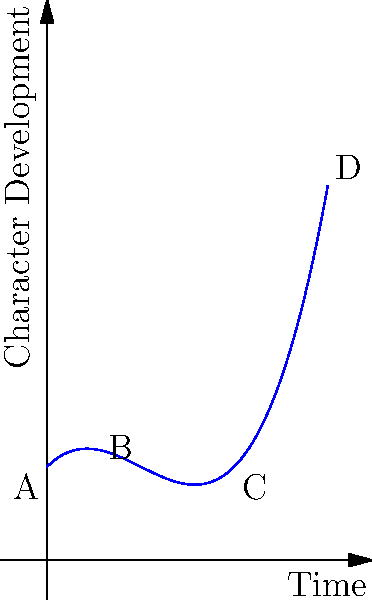In your novel, you're plotting a character's development arc over time. The curve above represents this arc, where the x-axis is time and the y-axis is the level of character development. If the function for this curve is $f(x) = 0.5x^3 - 1.5x^2 + x + 1$, at what point in time does the character experience the most significant setback in their development? To find the point of the most significant setback, we need to determine where the curve has its minimum value within the given time frame. This can be done by following these steps:

1) First, we need to find the derivative of the function:
   $f'(x) = 1.5x^2 - 3x + 1$

2) To find the critical points, set $f'(x) = 0$:
   $1.5x^2 - 3x + 1 = 0$

3) Solve this quadratic equation:
   $a = 1.5$, $b = -3$, $c = 1$
   $x = \frac{-b \pm \sqrt{b^2 - 4ac}}{2a}$
   $x = \frac{3 \pm \sqrt{9 - 6}}{3} = \frac{3 \pm \sqrt{3}}{3}$

4) This gives us two critical points:
   $x_1 = \frac{3 + \sqrt{3}}{3} \approx 1.58$
   $x_2 = \frac{3 - \sqrt{3}}{3} \approx 0.42$

5) Since we're looking for a minimum (setback) and the curve opens upward (positive coefficient for $x^3$), the minimum occurs at the larger x-value.

Therefore, the character experiences the most significant setback at $x \approx 1.58$ time units.
Answer: $\frac{3 + \sqrt{3}}{3}$ time units 